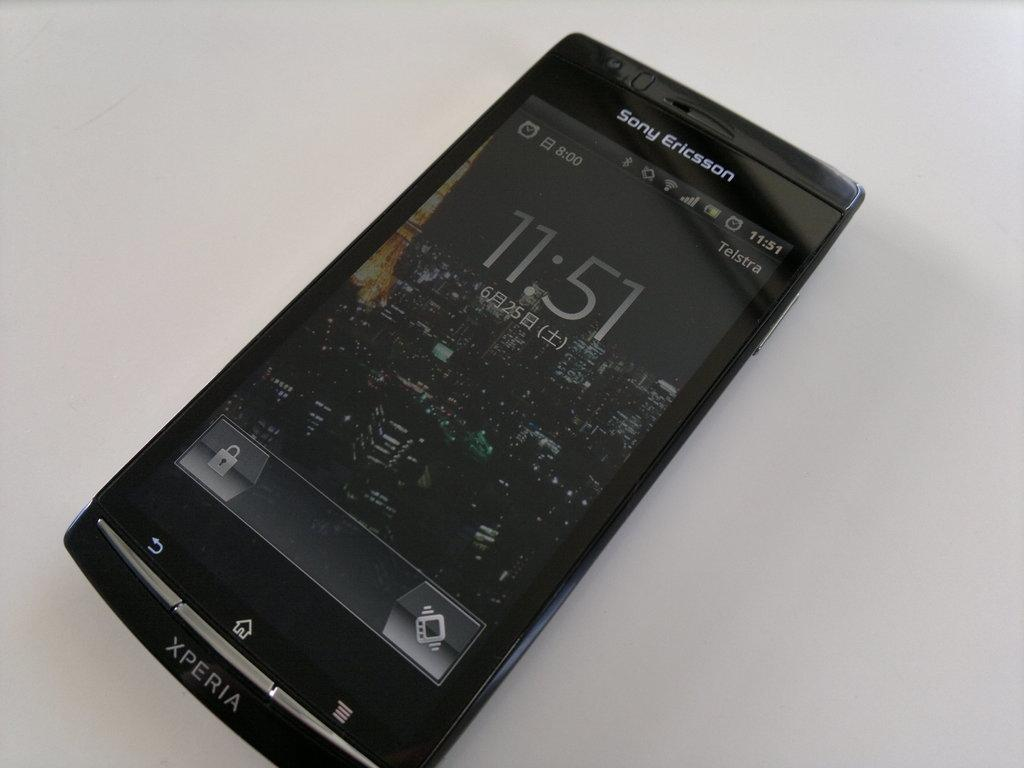<image>
Share a concise interpretation of the image provided. A Sony Ericsson smartphone shows that the current time is 11:51. 